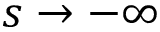Convert formula to latex. <formula><loc_0><loc_0><loc_500><loc_500>s \to - \infty</formula> 